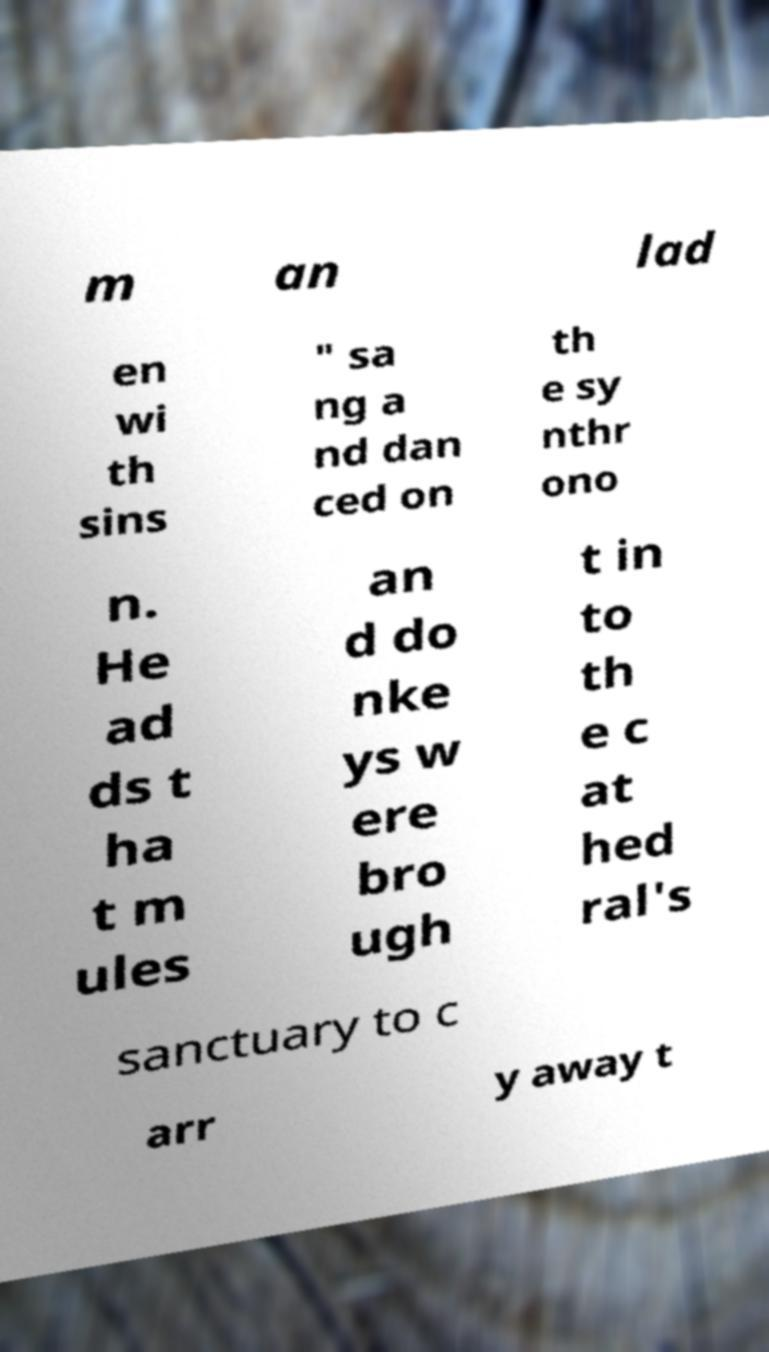What messages or text are displayed in this image? I need them in a readable, typed format. m an lad en wi th sins " sa ng a nd dan ced on th e sy nthr ono n. He ad ds t ha t m ules an d do nke ys w ere bro ugh t in to th e c at hed ral's sanctuary to c arr y away t 